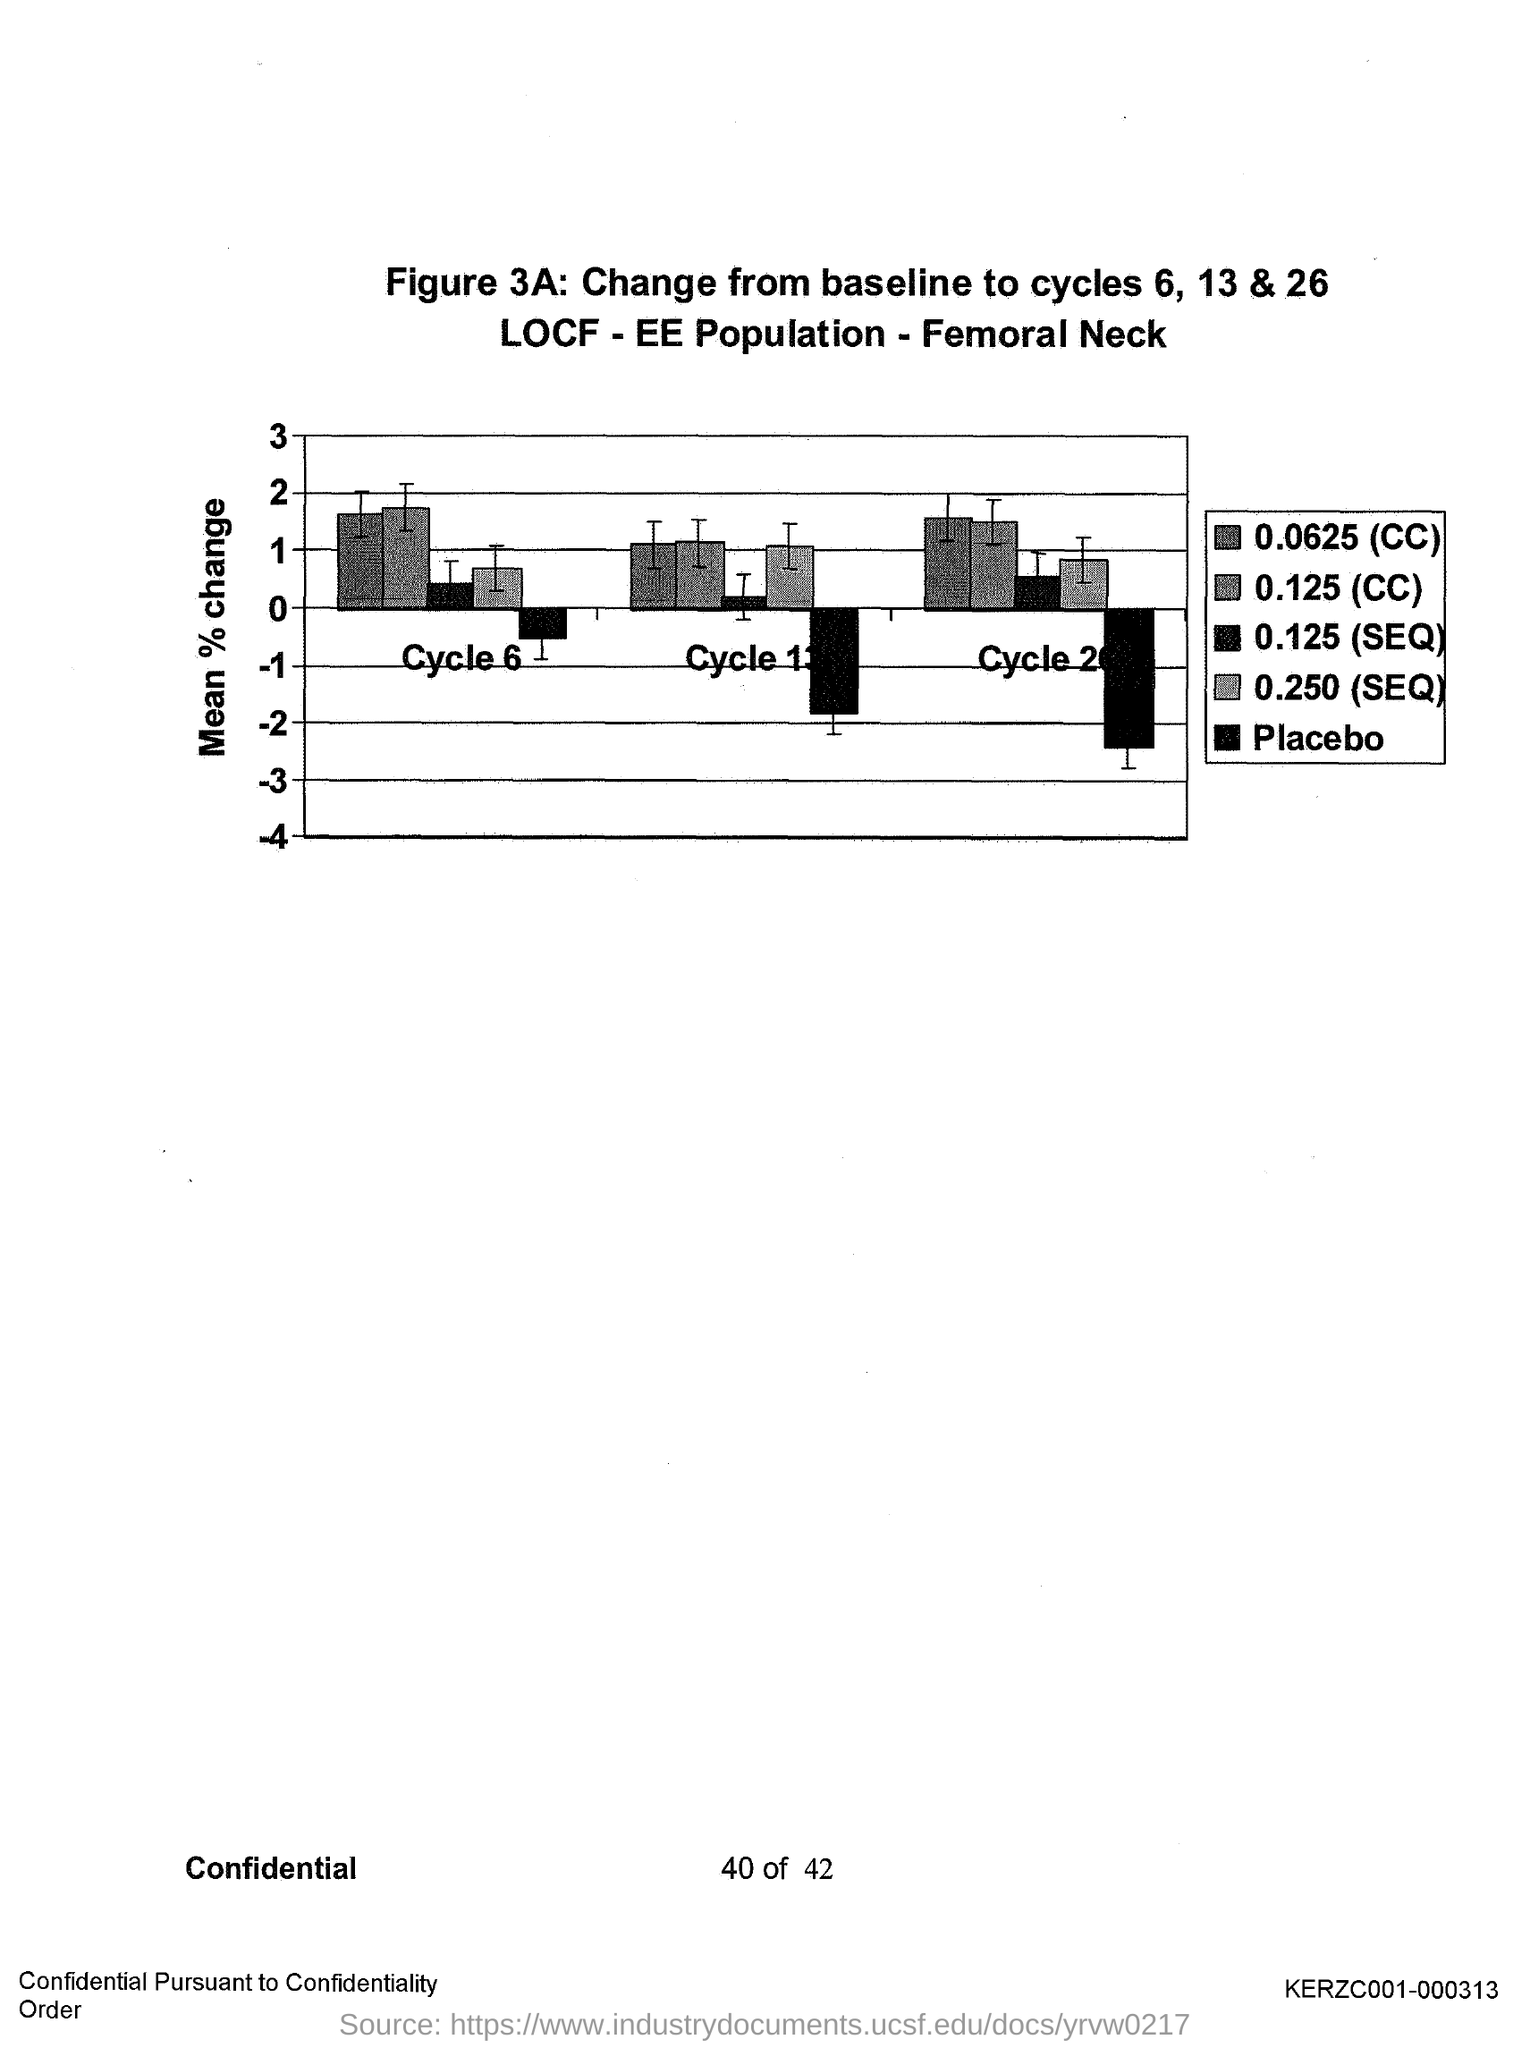What is plotted in the y-axis?
Your answer should be very brief. Mean % change. 